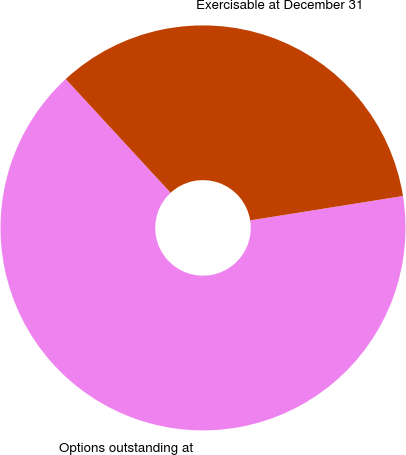Convert chart. <chart><loc_0><loc_0><loc_500><loc_500><pie_chart><fcel>Options outstanding at<fcel>Exercisable at December 31<nl><fcel>65.66%<fcel>34.34%<nl></chart> 